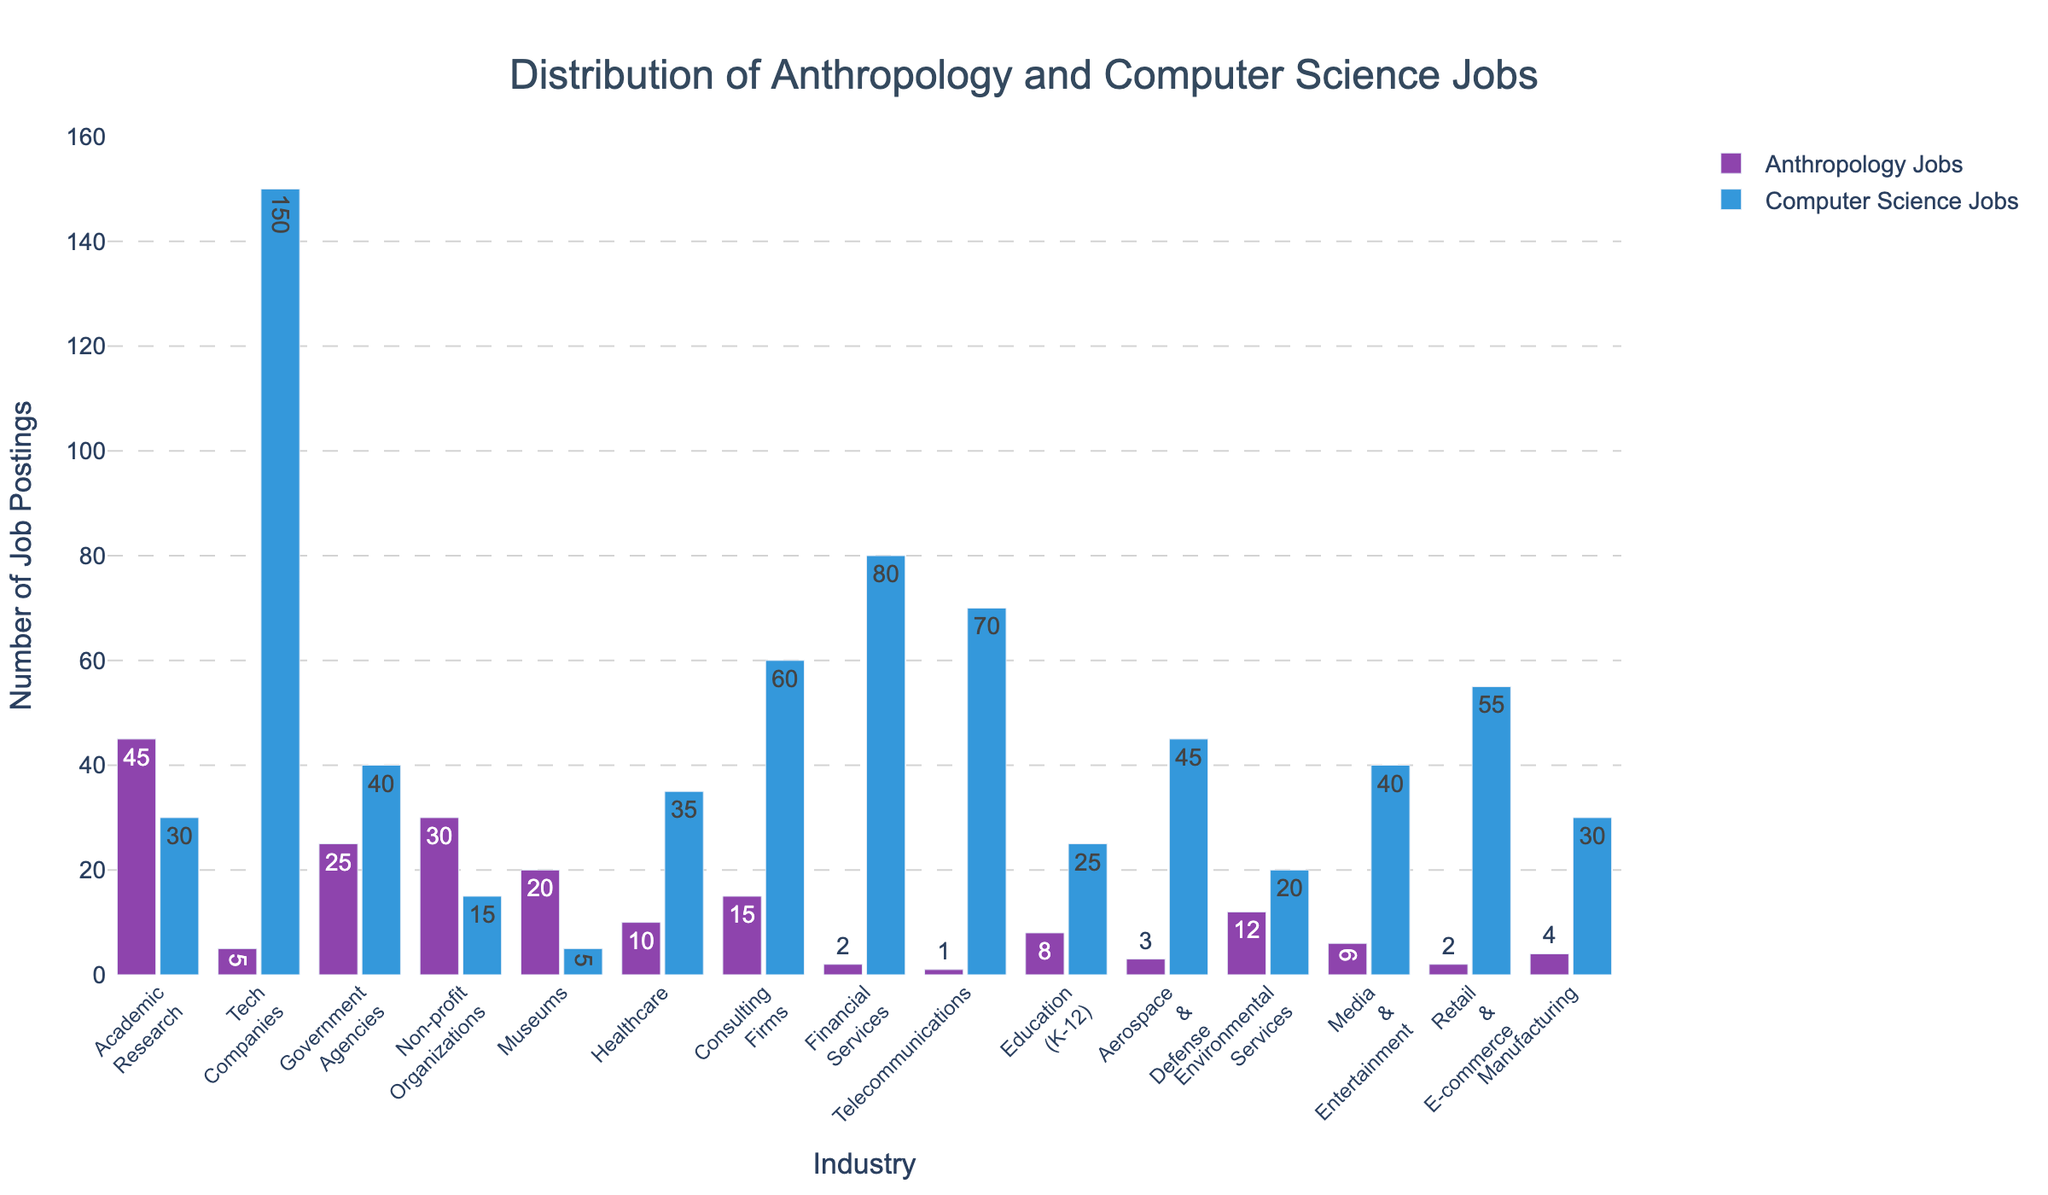How many more job postings are there in Tech Companies for Computer Science than for Anthropology? To answer this, refer to the bars representing job postings in Tech Companies for both fields. Subtract the number of Anthropology job postings (5) from the number of Computer Science job postings (150). Thus, 150 - 5 = 145.
Answer: 145 In which industry is the number of Anthropology job postings closest to the number of Computer Science job postings? Compare the values for both jobs across all industries. Government Agencies have 25 Anthropology job postings and 40 Computer Science job postings, which is the closest match, with a difference of 15 postings.
Answer: Government Agencies Which industry has the highest number of total job postings combining both Anthropology and Computer Science? Sum the number of job postings for both fields in each industry. The highest combined count is in Tech Companies with 5 (Anthropology) + 150 (Computer Science) = 155.
Answer: Tech Companies What is the average number of job postings for Anthropology across all industries shown? Sum all Anthropology job postings: 45 + 5 + 25 + 30 + 20 + 10 + 15 + 2 + 1 + 8 + 3 + 12 + 6 + 2 + 4 = 188. There are 15 industries, so the average is 188 / 15 ≈ 12.53.
Answer: 12.53 In which industry does Computer Science have the third highest number of job postings? List the job postings for Computer Science in descending order: Tech Companies (150), Financial Services (80), Telecommunications (70). Thus, Telecommunications has the third highest number.
Answer: Telecommunications Which industry has the least number of job postings for both fields combined? Sum the job postings for both fields for each industry and find the lowest total. Retail & E-commerce: 2 (Anthropology) + 55 (Computer Science) = 57.
Answer: Education (K-12) In how many industries do Computer Science job postings outnumber Anthropology job postings? Check each industry where Computer Science job postings are greater than Anthropology job postings: Tech Companies, Government Agencies, Healthcare, Consulting Firms, Financial Services, Telecommunications, Education (K-12), Aerospace & Defense, Media & Entertainment, Retail & E-commerce, Manufacturing. There are 11 total.
Answer: 11 What is the difference in the number of job postings between the industry with the highest number of Anthropology job postings and the industry with the lowest? The highest number of Anthropology job postings is in Academic Research (45) and the lowest in Telecommunications (1). The difference is 45 - 1 = 44.
Answer: 44 What is the median number of Computer Science job postings across all industries? List the Computer Science job postings in ascending order: 5, 15, 20, 25, 30, 30, 35, 40, 40, 45, 55, 60, 70, 80, 150. There are 15 values, so the median is the 8th value, which is 40.
Answer: 40 